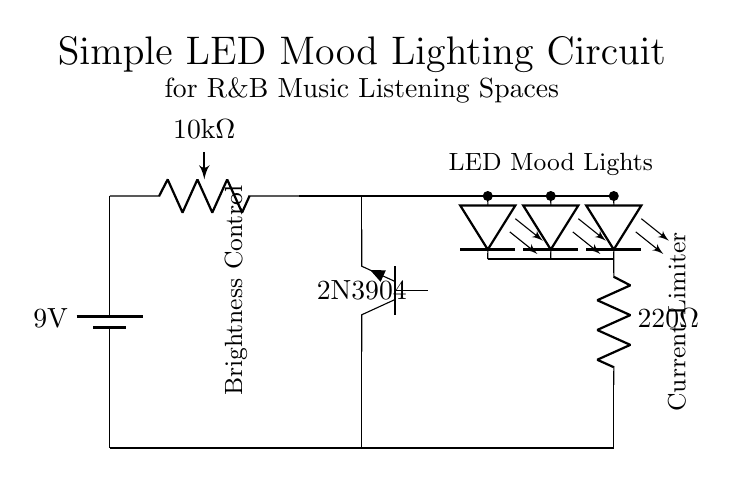What is the voltage source in the circuit? The circuit uses a 9V battery as the voltage source, which is indicated at the top left corner of the diagram.
Answer: 9V What type of transistor is used in this circuit? The circuit uses an NPN transistor, specifically a 2N3904, which is labeled in the diagram next to the transistor symbol.
Answer: 2N3904 How many LEDs are present in the circuit? There are three LEDs shown in the circuit diagram, which are located in a series arrangement based on their connection to the power source.
Answer: 3 What is the resistance value of the current limiting resistor? The current limiting resistor is labeled as 220 Ohms in the circuit, indicated by the resistor symbol and the accompanying text.
Answer: 220 Ohm What component is used for brightness control? The circuit includes a potentiometer labeled as 10k Ohm, which is used to adjust the brightness of the LEDs. This is positioned at the top of the circuit.
Answer: 10k Ohm potentiometer How does the potentiometer affect the circuit? The potentiometer regulates the amount of current flowing to the base of the transistor, thereby controlling the brightness of the LEDs by adjusting the transistor's conductivity. This affects how much current can flow to the LEDs, modifying their brightness based on the potentiometer's setting.
Answer: Controls brightness 